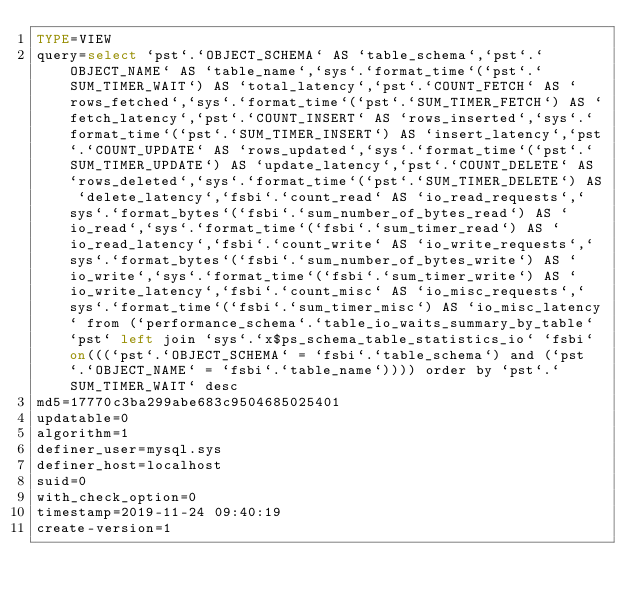<code> <loc_0><loc_0><loc_500><loc_500><_VisualBasic_>TYPE=VIEW
query=select `pst`.`OBJECT_SCHEMA` AS `table_schema`,`pst`.`OBJECT_NAME` AS `table_name`,`sys`.`format_time`(`pst`.`SUM_TIMER_WAIT`) AS `total_latency`,`pst`.`COUNT_FETCH` AS `rows_fetched`,`sys`.`format_time`(`pst`.`SUM_TIMER_FETCH`) AS `fetch_latency`,`pst`.`COUNT_INSERT` AS `rows_inserted`,`sys`.`format_time`(`pst`.`SUM_TIMER_INSERT`) AS `insert_latency`,`pst`.`COUNT_UPDATE` AS `rows_updated`,`sys`.`format_time`(`pst`.`SUM_TIMER_UPDATE`) AS `update_latency`,`pst`.`COUNT_DELETE` AS `rows_deleted`,`sys`.`format_time`(`pst`.`SUM_TIMER_DELETE`) AS `delete_latency`,`fsbi`.`count_read` AS `io_read_requests`,`sys`.`format_bytes`(`fsbi`.`sum_number_of_bytes_read`) AS `io_read`,`sys`.`format_time`(`fsbi`.`sum_timer_read`) AS `io_read_latency`,`fsbi`.`count_write` AS `io_write_requests`,`sys`.`format_bytes`(`fsbi`.`sum_number_of_bytes_write`) AS `io_write`,`sys`.`format_time`(`fsbi`.`sum_timer_write`) AS `io_write_latency`,`fsbi`.`count_misc` AS `io_misc_requests`,`sys`.`format_time`(`fsbi`.`sum_timer_misc`) AS `io_misc_latency` from (`performance_schema`.`table_io_waits_summary_by_table` `pst` left join `sys`.`x$ps_schema_table_statistics_io` `fsbi` on(((`pst`.`OBJECT_SCHEMA` = `fsbi`.`table_schema`) and (`pst`.`OBJECT_NAME` = `fsbi`.`table_name`)))) order by `pst`.`SUM_TIMER_WAIT` desc
md5=17770c3ba299abe683c9504685025401
updatable=0
algorithm=1
definer_user=mysql.sys
definer_host=localhost
suid=0
with_check_option=0
timestamp=2019-11-24 09:40:19
create-version=1</code> 